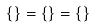Convert formula to latex. <formula><loc_0><loc_0><loc_500><loc_500>\{ \} = \{ \} = \{ \}</formula> 